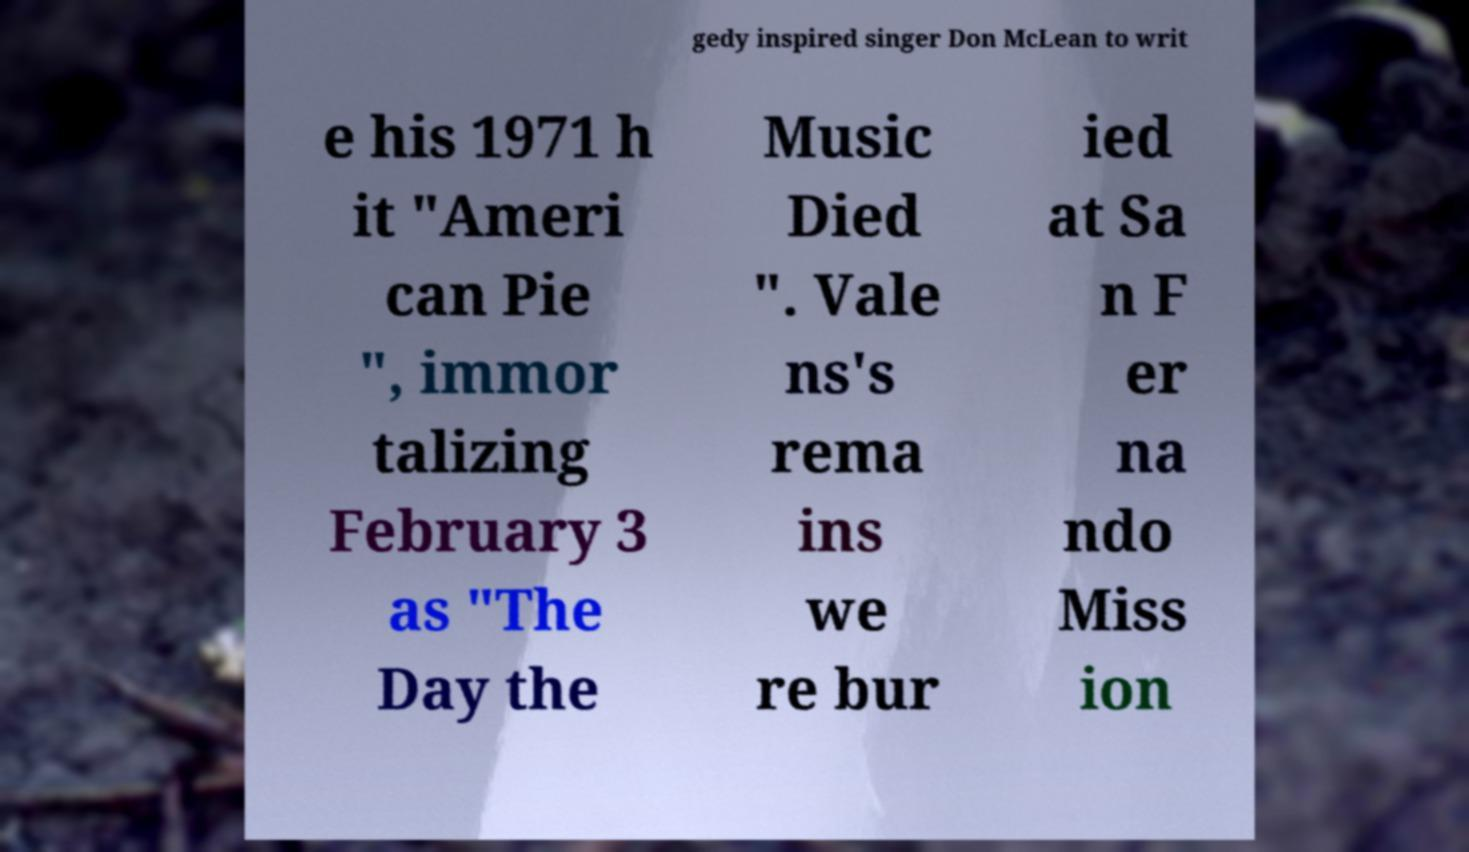Please identify and transcribe the text found in this image. gedy inspired singer Don McLean to writ e his 1971 h it "Ameri can Pie ", immor talizing February 3 as "The Day the Music Died ". Vale ns's rema ins we re bur ied at Sa n F er na ndo Miss ion 